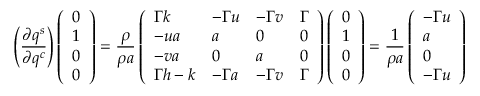<formula> <loc_0><loc_0><loc_500><loc_500>\left ( \frac { \partial q ^ { s } } { \partial q ^ { c } } \right ) \left ( \begin{array} { l } { 0 } \\ { 1 } \\ { 0 } \\ { 0 } \end{array} \right ) = \frac { \rho } { \rho a } \left ( \begin{array} { l l l l } { \Gamma k } & { - \Gamma u } & { - \Gamma v } & { \Gamma } \\ { - u a } & { a } & { 0 } & { 0 } \\ { - v a } & { 0 } & { a } & { 0 } \\ { \Gamma h - k } & { - \Gamma a } & { - \Gamma v } & { \Gamma } \end{array} \right ) \left ( \begin{array} { l } { 0 } \\ { 1 } \\ { 0 } \\ { 0 } \end{array} \right ) = \frac { 1 } { \rho a } \left ( \begin{array} { l } { - \Gamma u } \\ { a } \\ { 0 } \\ { - \Gamma u } \end{array} \right )</formula> 